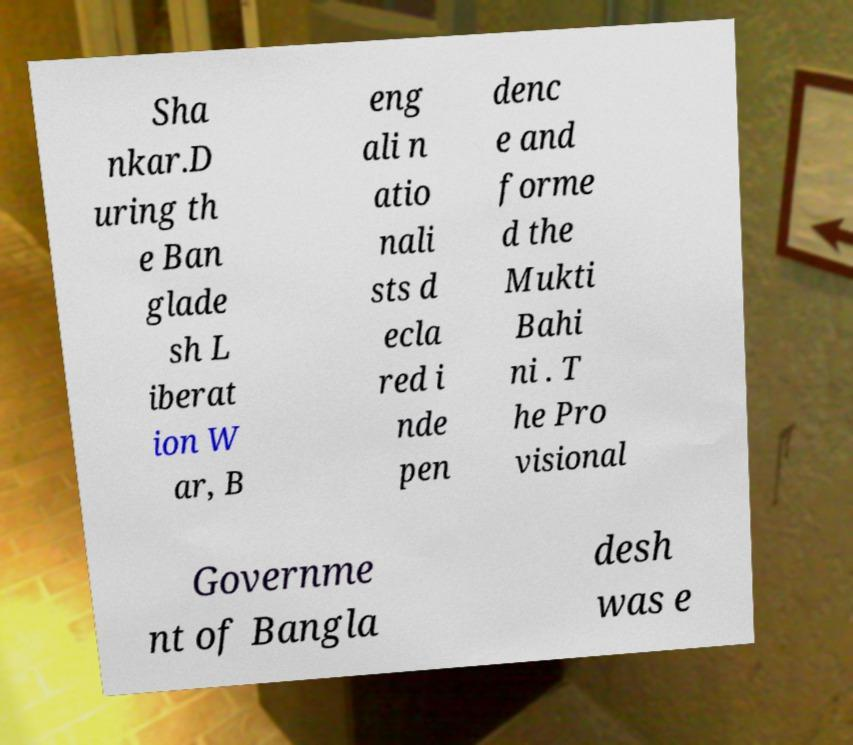There's text embedded in this image that I need extracted. Can you transcribe it verbatim? Sha nkar.D uring th e Ban glade sh L iberat ion W ar, B eng ali n atio nali sts d ecla red i nde pen denc e and forme d the Mukti Bahi ni . T he Pro visional Governme nt of Bangla desh was e 